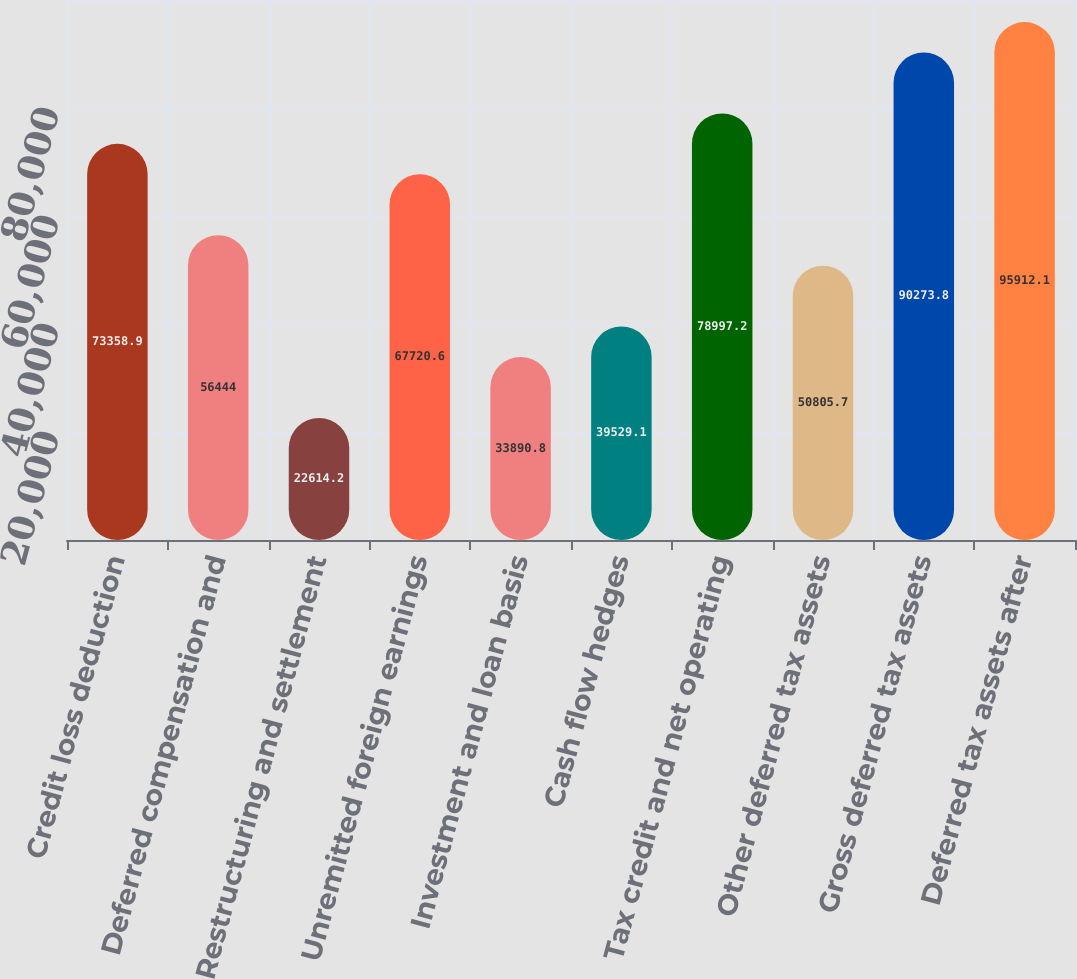<chart> <loc_0><loc_0><loc_500><loc_500><bar_chart><fcel>Credit loss deduction<fcel>Deferred compensation and<fcel>Restructuring and settlement<fcel>Unremitted foreign earnings<fcel>Investment and loan basis<fcel>Cash flow hedges<fcel>Tax credit and net operating<fcel>Other deferred tax assets<fcel>Gross deferred tax assets<fcel>Deferred tax assets after<nl><fcel>73358.9<fcel>56444<fcel>22614.2<fcel>67720.6<fcel>33890.8<fcel>39529.1<fcel>78997.2<fcel>50805.7<fcel>90273.8<fcel>95912.1<nl></chart> 